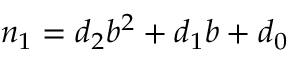<formula> <loc_0><loc_0><loc_500><loc_500>n _ { 1 } = d _ { 2 } b ^ { 2 } + d _ { 1 } b + d _ { 0 }</formula> 